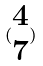<formula> <loc_0><loc_0><loc_500><loc_500>( \begin{matrix} 4 \\ 7 \end{matrix} )</formula> 